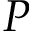<formula> <loc_0><loc_0><loc_500><loc_500>P</formula> 